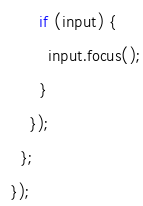<code> <loc_0><loc_0><loc_500><loc_500><_JavaScript_>        if (input) {
          input.focus();
        }
      });
    };
  });
</code> 